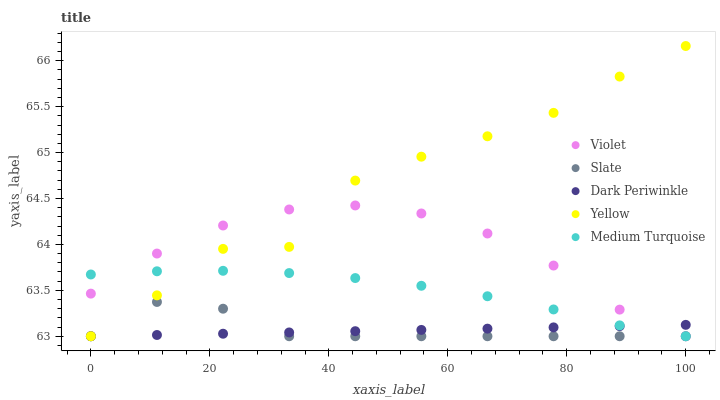Does Dark Periwinkle have the minimum area under the curve?
Answer yes or no. Yes. Does Yellow have the maximum area under the curve?
Answer yes or no. Yes. Does Slate have the minimum area under the curve?
Answer yes or no. No. Does Slate have the maximum area under the curve?
Answer yes or no. No. Is Dark Periwinkle the smoothest?
Answer yes or no. Yes. Is Yellow the roughest?
Answer yes or no. Yes. Is Slate the smoothest?
Answer yes or no. No. Is Slate the roughest?
Answer yes or no. No. Does Medium Turquoise have the lowest value?
Answer yes or no. Yes. Does Yellow have the highest value?
Answer yes or no. Yes. Does Slate have the highest value?
Answer yes or no. No. Does Yellow intersect Dark Periwinkle?
Answer yes or no. Yes. Is Yellow less than Dark Periwinkle?
Answer yes or no. No. Is Yellow greater than Dark Periwinkle?
Answer yes or no. No. 